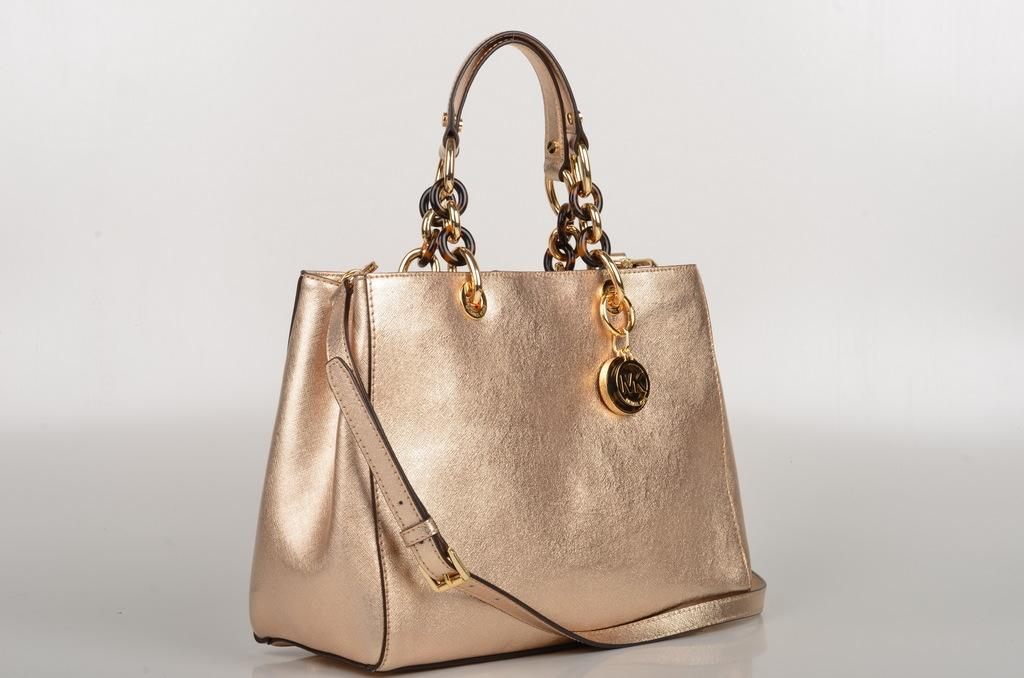What type of handbag is visible in the image? There is a golden handbag in the image. Where is the handbag located? The handbag is on a table. What type of cloud can be seen in the image? There is no cloud present in the image; it only features a golden handbag on a table. What type of tin is visible in the image? There is no tin present in the image; it only features a golden handbag on a table. 